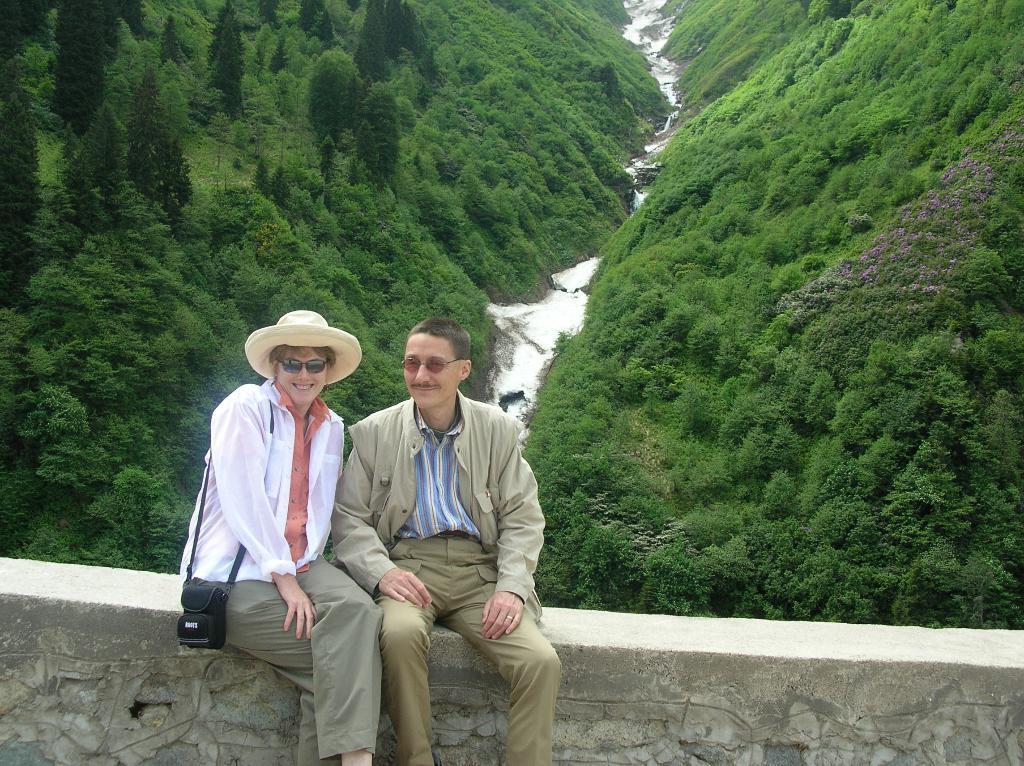How would you summarize this image in a sentence or two? In this image we can see two persons, one of them is wearing a hat, and a camera, there are trees, and the river. 